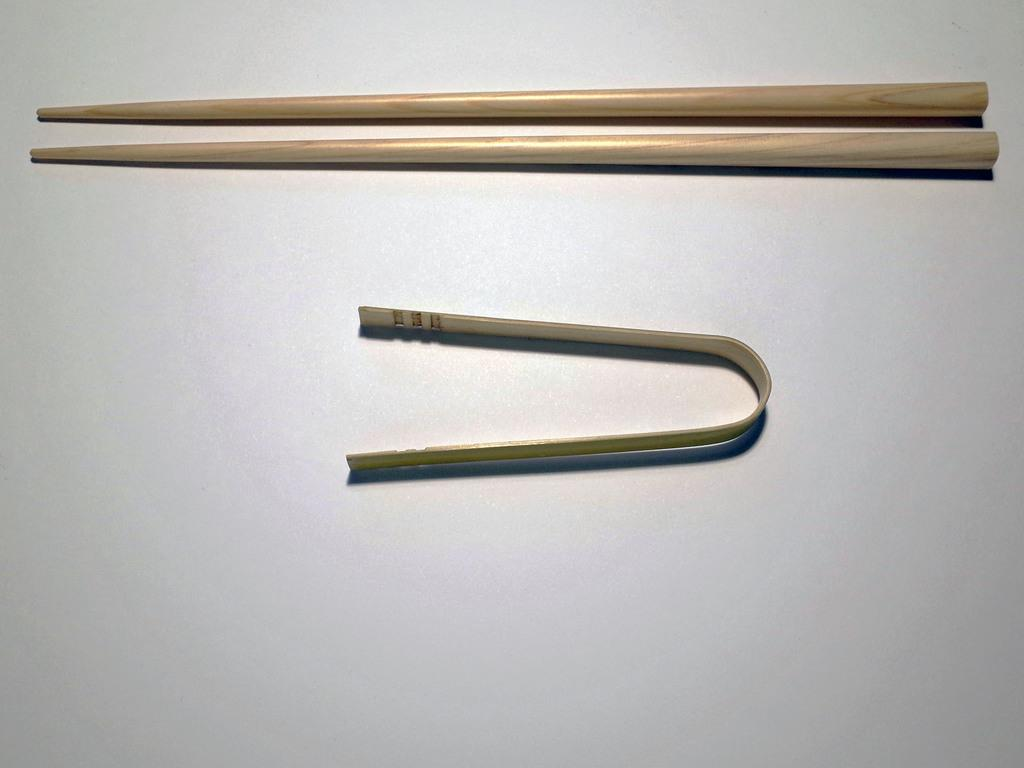What color is the background of the image? The background of the image is white. What type of objects can be seen in the image? There are three metal items in the image. How many cows are visible in the image? There are no cows present in the image; it features three metal items against a white background. 